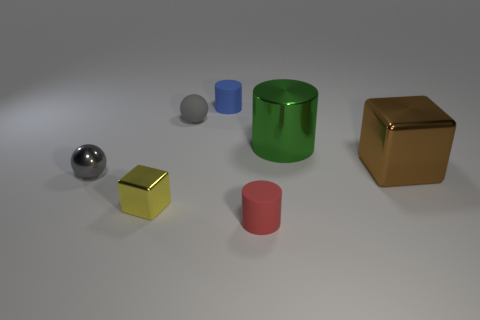Do the blue matte object and the small yellow metal object have the same shape?
Your answer should be very brief. No. There is a metal thing that is both right of the tiny gray shiny thing and in front of the brown block; what is its color?
Offer a very short reply. Yellow. What is the size of the metal object that is the same color as the small rubber sphere?
Ensure brevity in your answer.  Small. How many tiny objects are either green cylinders or gray matte blocks?
Offer a terse response. 0. Is there any other thing that has the same color as the metallic cylinder?
Offer a terse response. No. There is a big green object behind the small metallic thing that is in front of the small shiny thing that is behind the yellow metallic cube; what is it made of?
Make the answer very short. Metal. What number of rubber objects are either small cubes or small gray objects?
Make the answer very short. 1. How many green objects are either matte cylinders or large metallic cylinders?
Your response must be concise. 1. Does the rubber cylinder behind the small gray rubber object have the same color as the metal cylinder?
Offer a very short reply. No. Is the brown cube made of the same material as the small yellow thing?
Your response must be concise. Yes. 